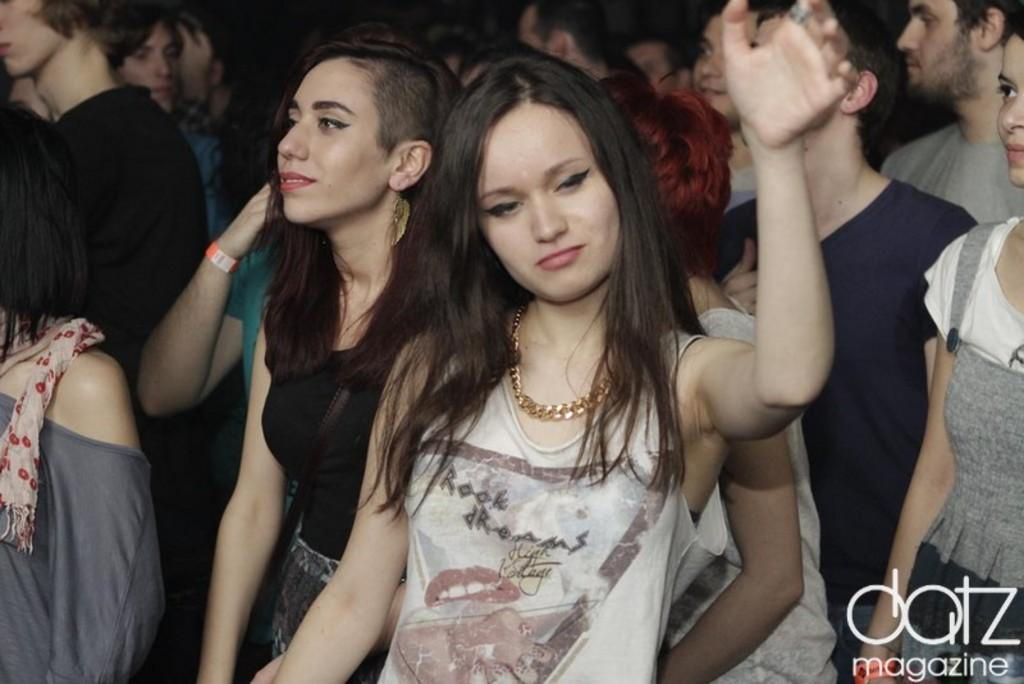Who or what can be seen in the image? There are people in the image. Is there any text or marking visible in the image? Yes, there is a watermark at the bottom right side of the image. Can you see a lake in the background of the image? There is no lake visible in the image. Is there a mailbox present in the image? There is no mailbox mentioned or visible in the image. 